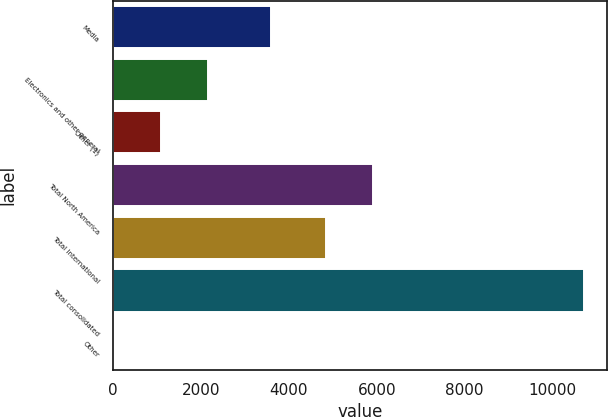<chart> <loc_0><loc_0><loc_500><loc_500><bar_chart><fcel>Media<fcel>Electronics and other general<fcel>Other (1)<fcel>Total North America<fcel>Total International<fcel>Total consolidated<fcel>Other<nl><fcel>3582<fcel>2156.6<fcel>1087.3<fcel>5911.3<fcel>4842<fcel>10711<fcel>18<nl></chart> 